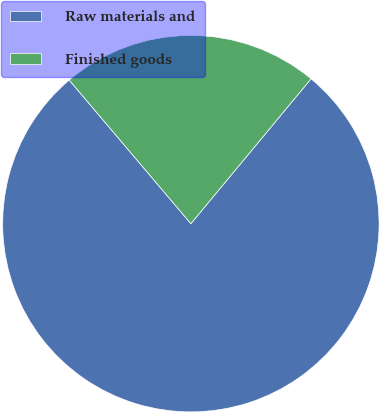Convert chart to OTSL. <chart><loc_0><loc_0><loc_500><loc_500><pie_chart><fcel>Raw materials and<fcel>Finished goods<nl><fcel>77.79%<fcel>22.21%<nl></chart> 